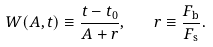Convert formula to latex. <formula><loc_0><loc_0><loc_500><loc_500>W ( A , t ) \equiv \frac { t - t _ { 0 } } { A + r } , \quad r \equiv \frac { F _ { \mathrm b } } { F _ { \mathrm s } } .</formula> 